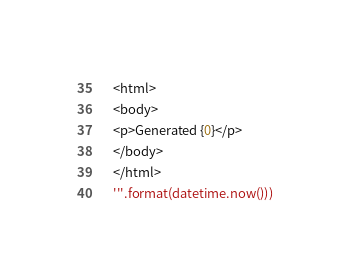Convert code to text. <code><loc_0><loc_0><loc_500><loc_500><_Python_>    <html>
    <body>
    <p>Generated {0}</p>
    </body>
    </html>
    '''.format(datetime.now()))</code> 